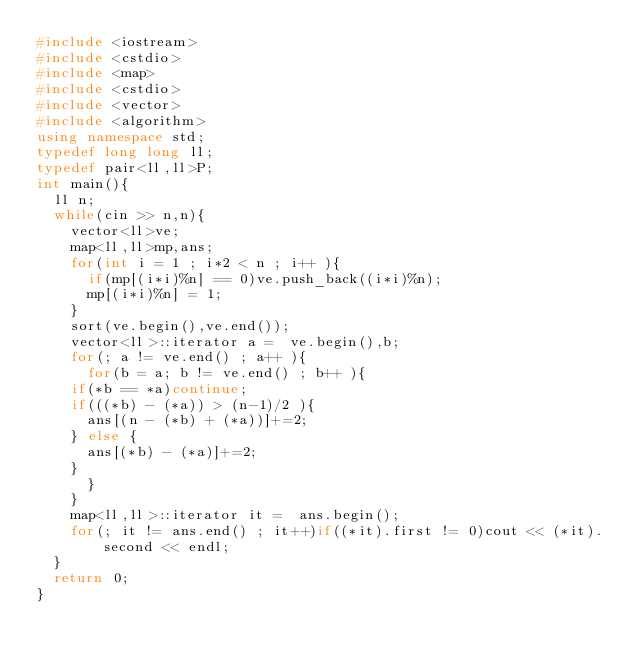<code> <loc_0><loc_0><loc_500><loc_500><_C++_>#include <iostream>
#include <cstdio>
#include <map>
#include <cstdio>
#include <vector>
#include <algorithm>
using namespace std;
typedef long long ll;
typedef pair<ll,ll>P;
int main(){
  ll n;
  while(cin >> n,n){
    vector<ll>ve;
    map<ll,ll>mp,ans;
    for(int i = 1 ; i*2 < n ; i++ ){
      if(mp[(i*i)%n] == 0)ve.push_back((i*i)%n);
      mp[(i*i)%n] = 1;
    }
    sort(ve.begin(),ve.end());
    vector<ll>::iterator a =  ve.begin(),b;
    for(; a != ve.end() ; a++ ){
      for(b = a; b != ve.end() ; b++ ){
	if(*b == *a)continue;
	if(((*b) - (*a)) > (n-1)/2 ){
	  ans[(n - (*b) + (*a))]+=2;
	} else {
	  ans[(*b) - (*a)]+=2;
	}
      }
    }
    map<ll,ll>::iterator it =  ans.begin();
    for(; it != ans.end() ; it++)if((*it).first != 0)cout << (*it).second << endl;
  }
  return 0;
}</code> 